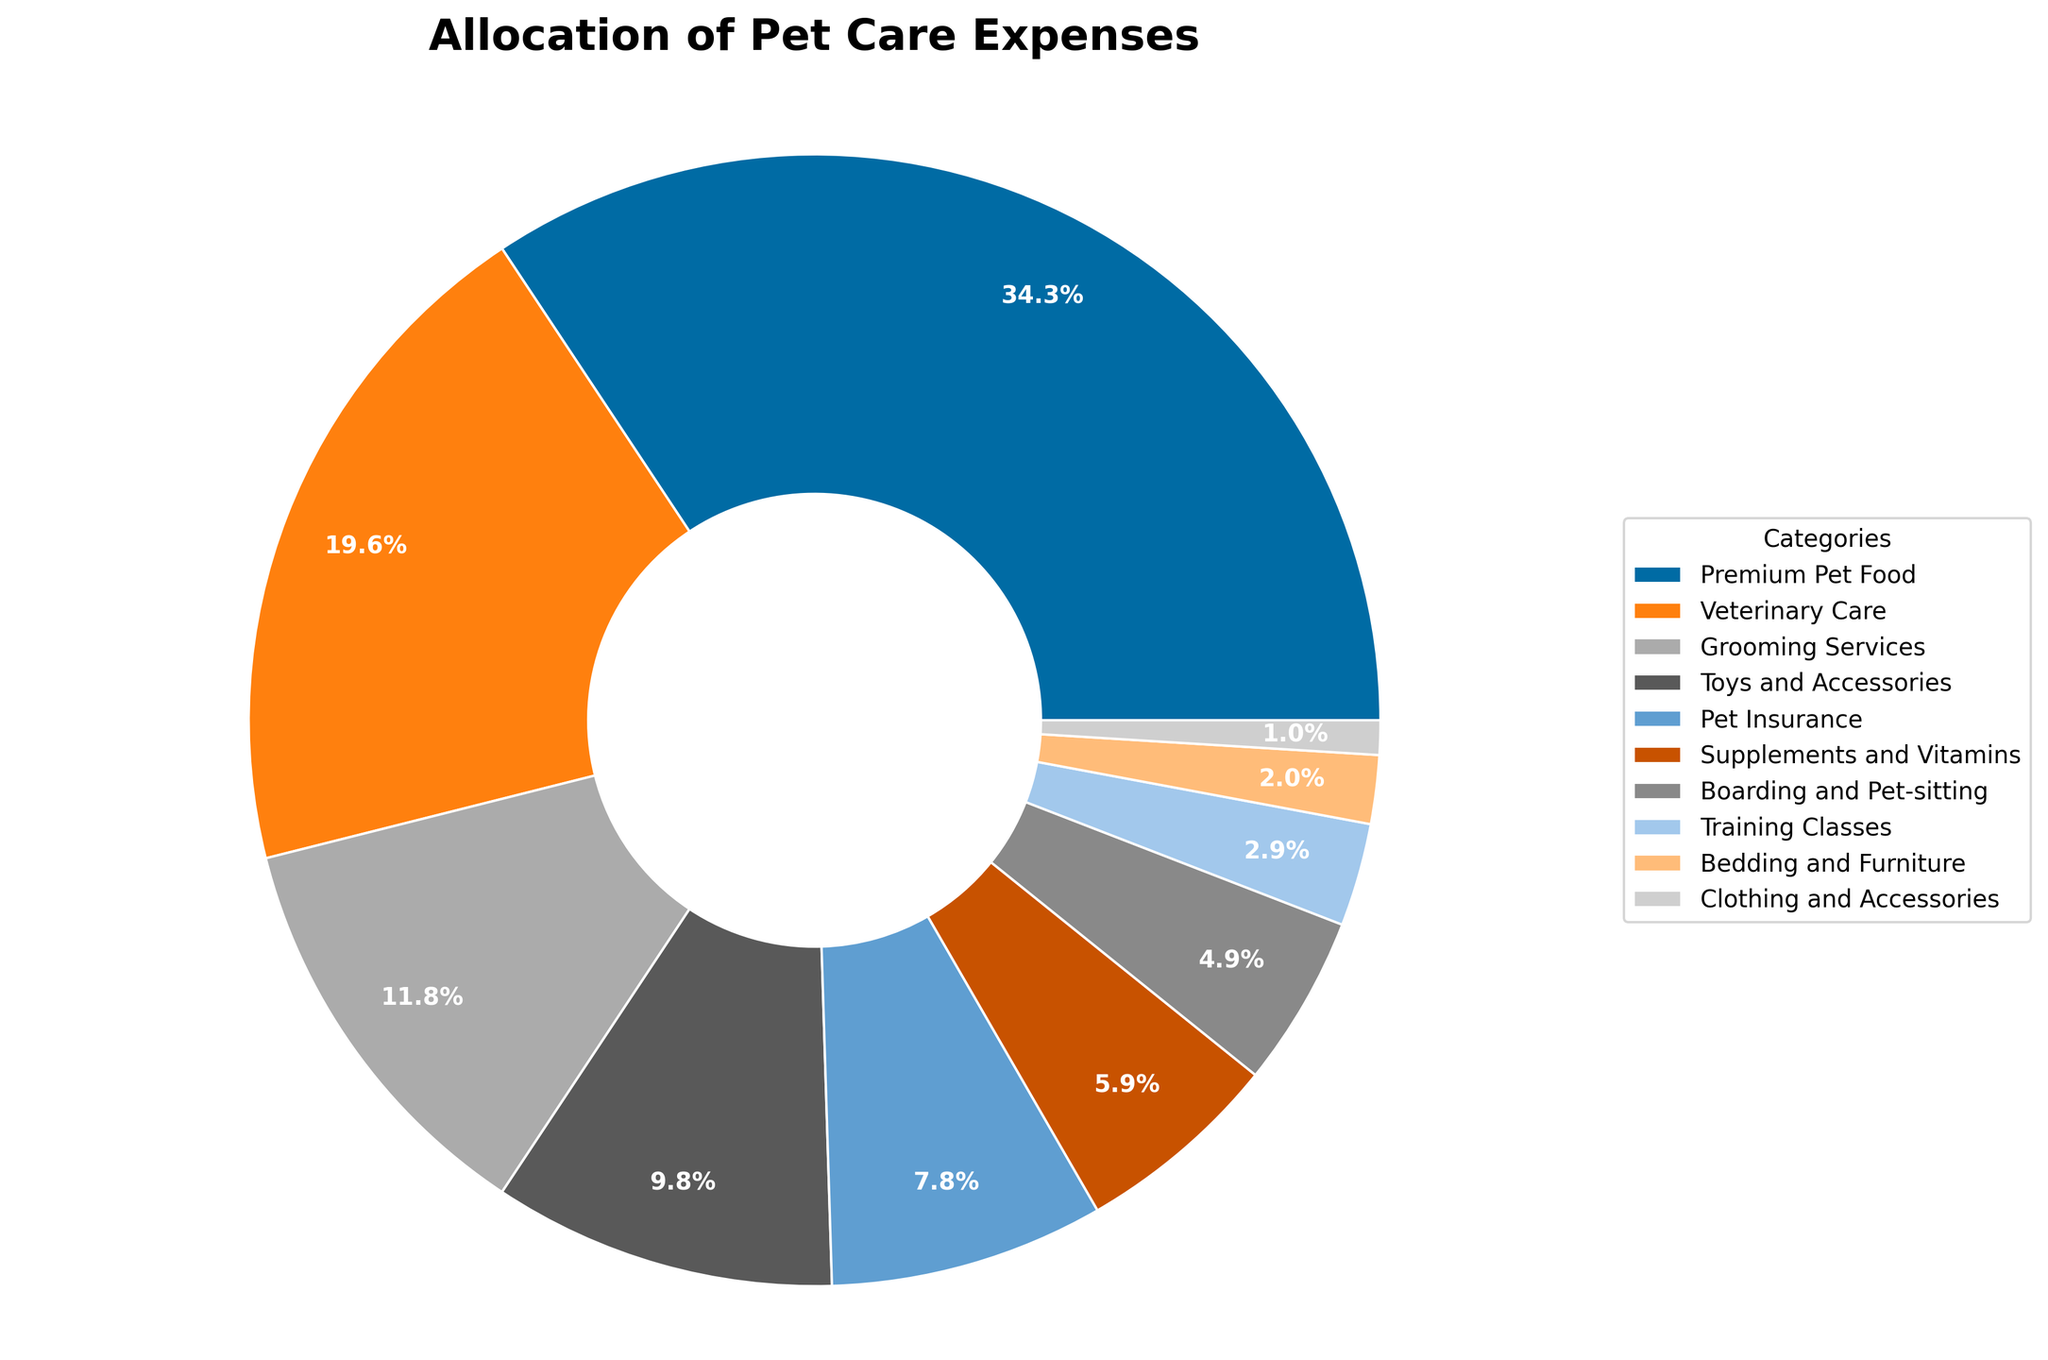Which category has the highest allocation of pet care expenses? The category with the highest allocation is the one with the largest slice in the pie chart. In this case, "Premium Pet Food" has the largest slice.
Answer: Premium Pet Food What is the combined percentage of expenses allocated to Toys and Accessories and Pet Insurance? To find the combined percentage, add the percentages of "Toys and Accessories" (10%) and "Pet Insurance" (8%). 10% + 8% equals 18%.
Answer: 18% How does the percentage allocated to Veterinary Care compare to that of Grooming Services? The slice for "Veterinary Care" represents 20% of the expenses, while the slice for "Grooming Services" represents 12%. Therefore, the percentage for "Veterinary Care" is higher than that for "Grooming Services".
Answer: Veterinary Care is higher What is the difference in allocation between Boarding and Pet-sitting and Supplements and Vitamins? The allocation for "Supplements and Vitamins" is 6% and for "Boarding and Pet-sitting" is 5%. Subtract 5% from 6% to get the difference, which is 1%.
Answer: 1% Which two categories have the smallest allocations and what are their percentages? The two smallest slices are for "Clothing and Accessories" (1%) and "Bedding and Furniture" (2%).
Answer: Clothing and Accessories (1%), Bedding and Furniture (2%) Is the allocation for Training Classes more or less than half of that for Grooming Services? The percentage for "Training Classes" is 3%, and the percentage for "Grooming Services" is 12%. Half of 12% is 6%, which is clearly more than 3%.
Answer: Less What is the total percentage allocated to Premium Pet Food, Pet Insurance, and Veterinary Care together? Add the percentages for "Premium Pet Food" (35%), "Pet Insurance" (8%), and "Veterinary Care" (20%). 35% + 8% + 20% equals 63%.
Answer: 63% How many categories have an allocation percentage that is greater than 10%? The categories with allocations greater than 10% are "Premium Pet Food" (35%), "Veterinary Care" (20%), and "Grooming Services" (12%), totaling three categories.
Answer: 3 